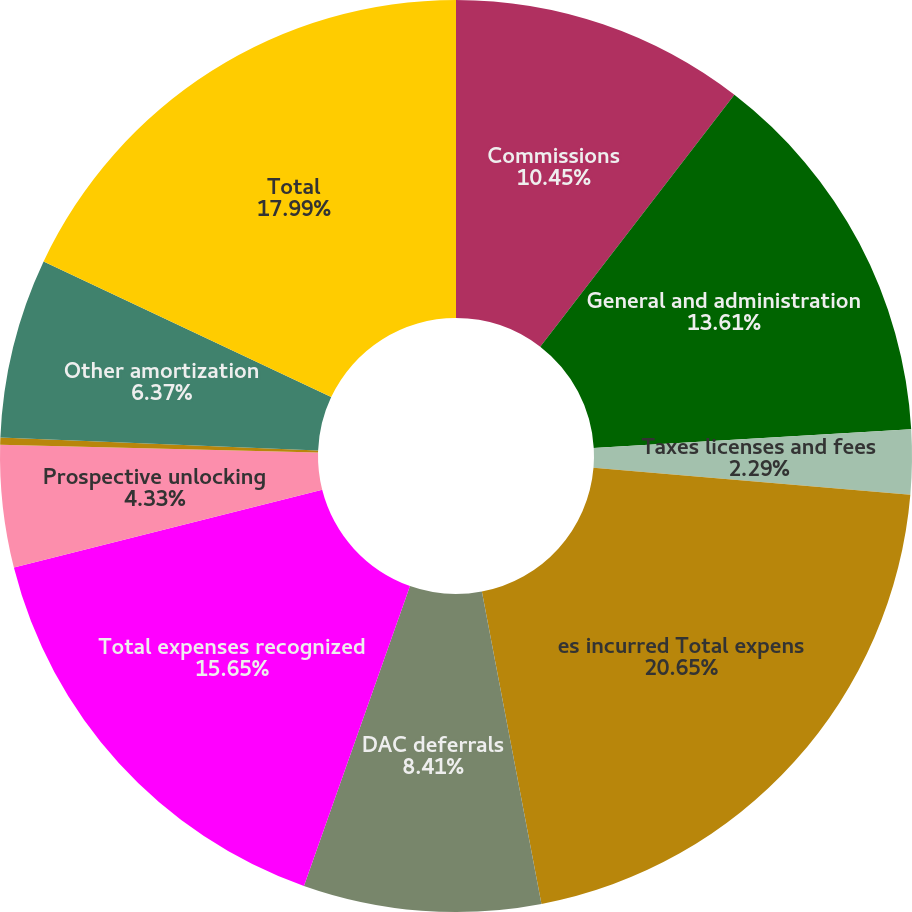<chart> <loc_0><loc_0><loc_500><loc_500><pie_chart><fcel>Commissions<fcel>General and administration<fcel>Taxes licenses and fees<fcel>es incurred Total expens<fcel>DAC deferrals<fcel>Total expenses recognized<fcel>Prospective unlocking<fcel>Retrospective unlocking<fcel>Other amortization<fcel>Total<nl><fcel>10.45%<fcel>13.61%<fcel>2.29%<fcel>20.64%<fcel>8.41%<fcel>15.65%<fcel>4.33%<fcel>0.25%<fcel>6.37%<fcel>17.98%<nl></chart> 